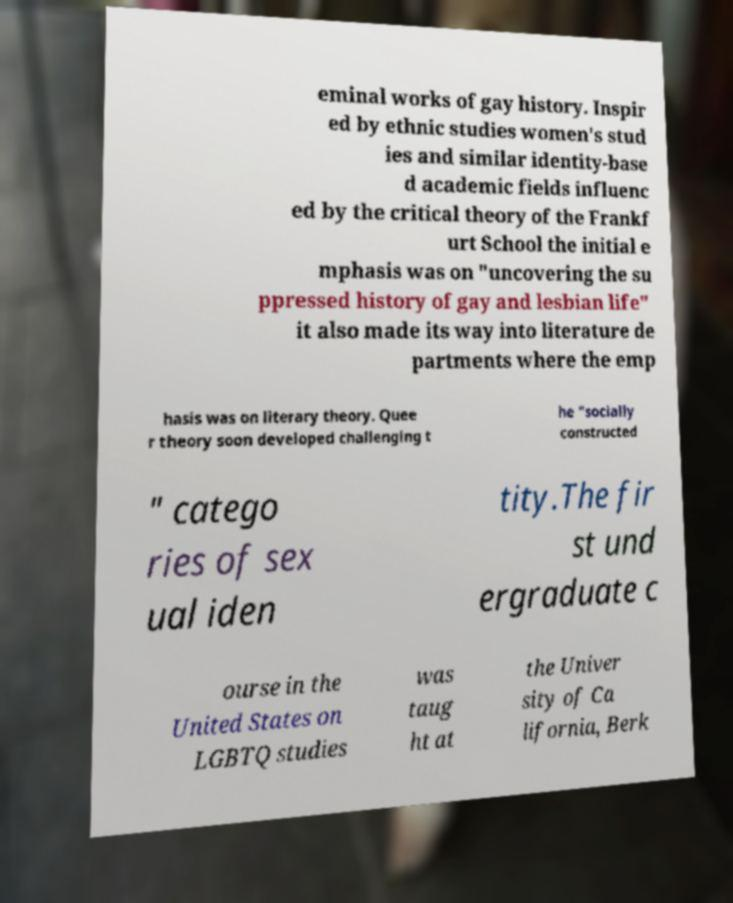Can you read and provide the text displayed in the image?This photo seems to have some interesting text. Can you extract and type it out for me? eminal works of gay history. Inspir ed by ethnic studies women's stud ies and similar identity-base d academic fields influenc ed by the critical theory of the Frankf urt School the initial e mphasis was on "uncovering the su ppressed history of gay and lesbian life" it also made its way into literature de partments where the emp hasis was on literary theory. Quee r theory soon developed challenging t he "socially constructed " catego ries of sex ual iden tity.The fir st und ergraduate c ourse in the United States on LGBTQ studies was taug ht at the Univer sity of Ca lifornia, Berk 